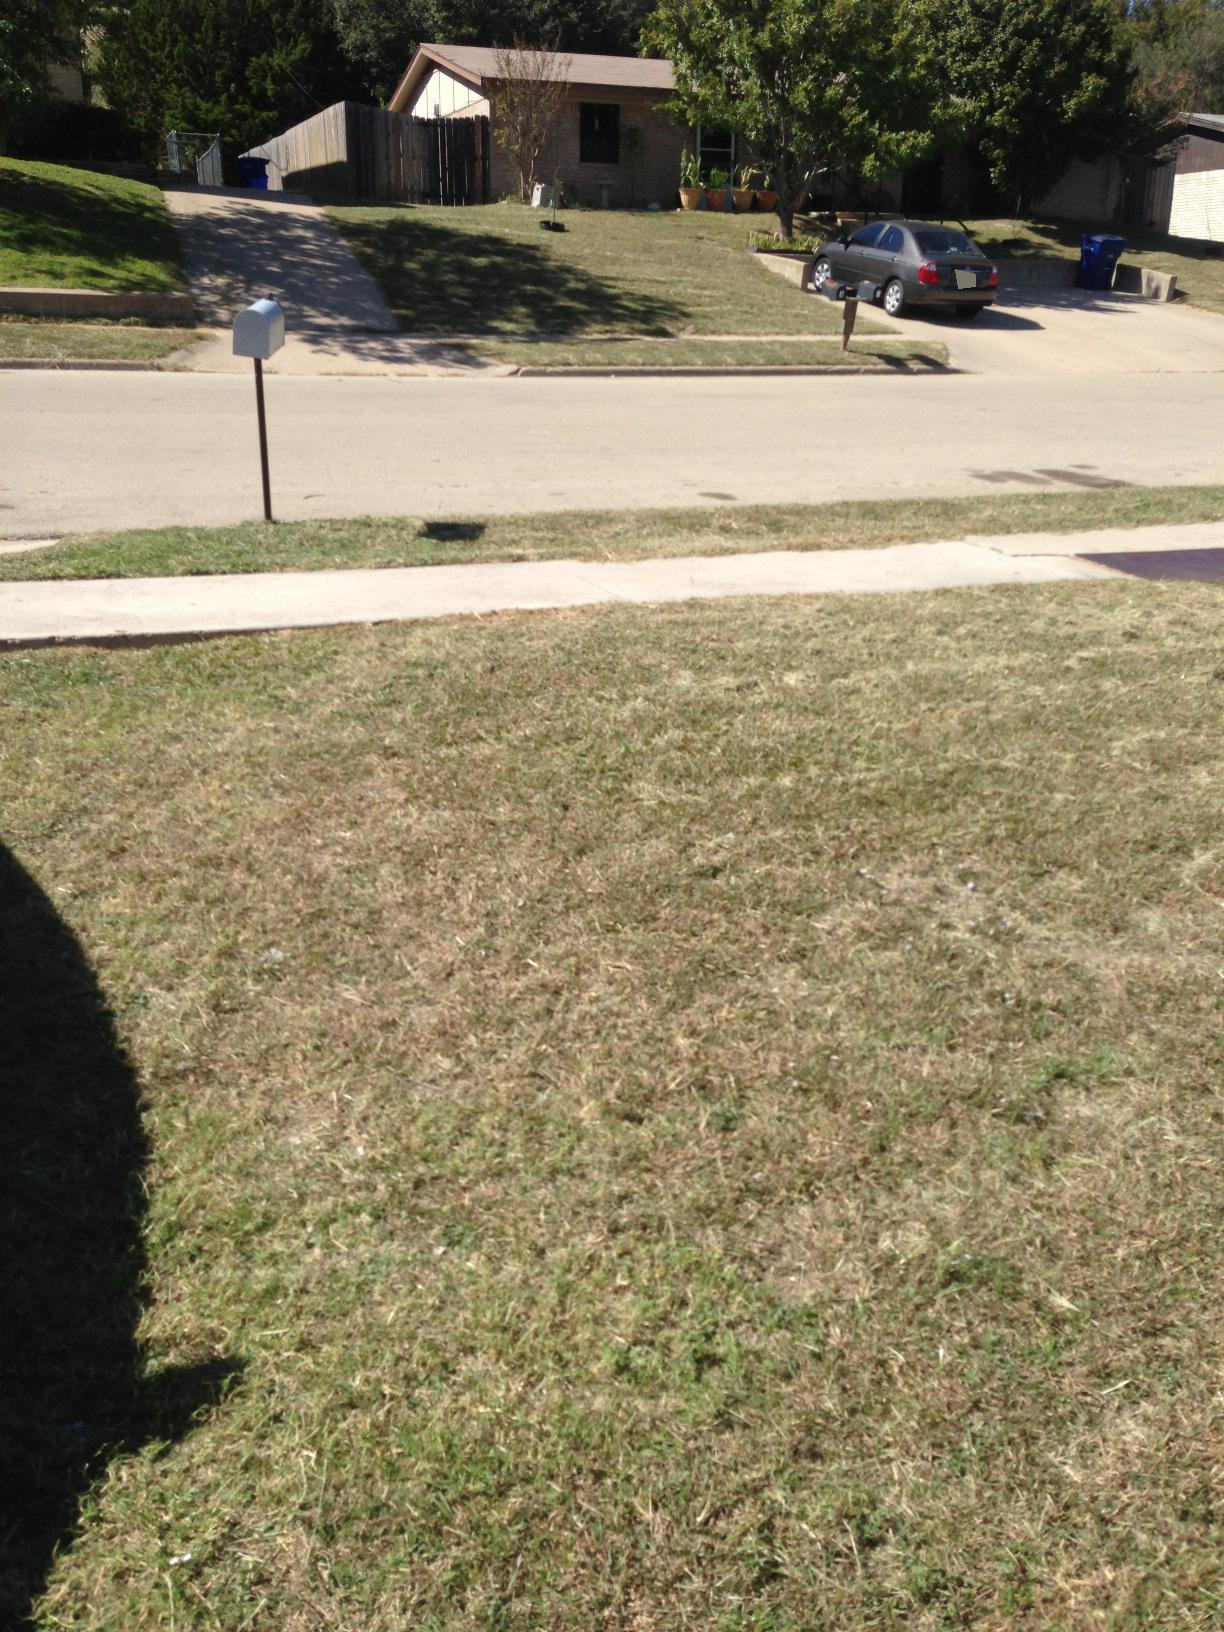How does the setting of this photo reflect suburban life? The setting of this photo embodies many typical aspects of suburban life. The quiet, tree-lined street with well-kept lawns and a mix of practical and decorative elements, like the mailbox and potted plants, reflects an environment of both comfort and community. The parked car in the driveway highlights daily routines and commutes. The neat houses, spaced at a comfortable distance, suggest a close-knit but private community where residents likely enjoy a balance between social interaction and solitude.  What do the elements in the image suggest about the people who live here? The elements in the image suggest that the people who live here value a clean and orderly environment, as evidenced by the well-maintained lawns and houses. The presence of a car in the driveway hints that the residents have a routine structured around daily commutes or errands. The potted plants and neatly trimmed grass suggest that the homeowners take pride in their property and enjoy maintaining it. The overall scene portrays a peaceful and relatively quiet neighborhood, indicating that the residents likely appreciate tranquility and community. 